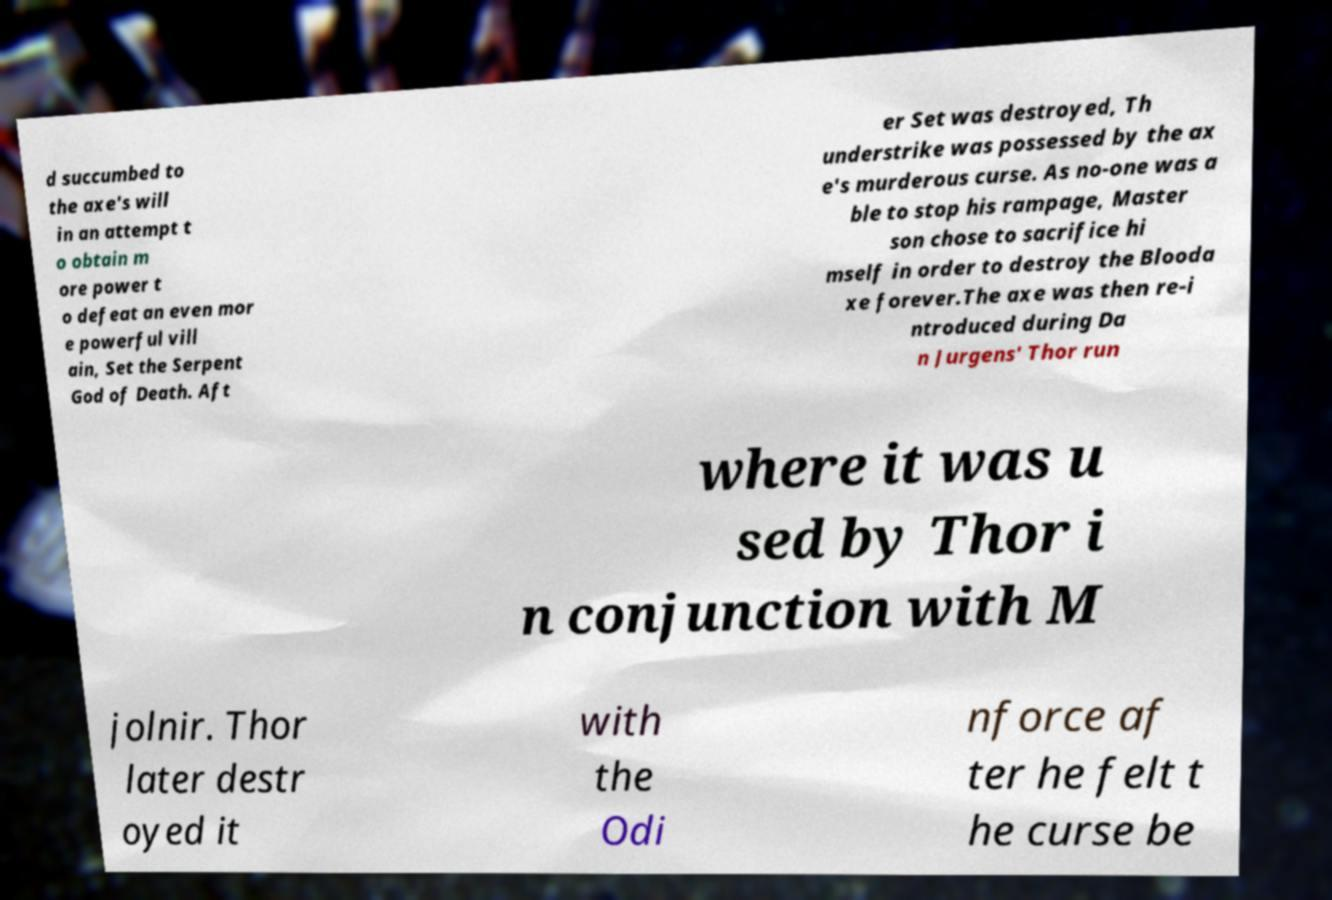What messages or text are displayed in this image? I need them in a readable, typed format. d succumbed to the axe's will in an attempt t o obtain m ore power t o defeat an even mor e powerful vill ain, Set the Serpent God of Death. Aft er Set was destroyed, Th understrike was possessed by the ax e's murderous curse. As no-one was a ble to stop his rampage, Master son chose to sacrifice hi mself in order to destroy the Blooda xe forever.The axe was then re-i ntroduced during Da n Jurgens' Thor run where it was u sed by Thor i n conjunction with M jolnir. Thor later destr oyed it with the Odi nforce af ter he felt t he curse be 